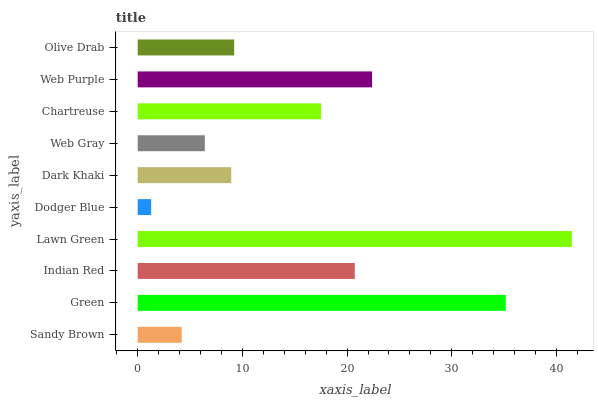Is Dodger Blue the minimum?
Answer yes or no. Yes. Is Lawn Green the maximum?
Answer yes or no. Yes. Is Green the minimum?
Answer yes or no. No. Is Green the maximum?
Answer yes or no. No. Is Green greater than Sandy Brown?
Answer yes or no. Yes. Is Sandy Brown less than Green?
Answer yes or no. Yes. Is Sandy Brown greater than Green?
Answer yes or no. No. Is Green less than Sandy Brown?
Answer yes or no. No. Is Chartreuse the high median?
Answer yes or no. Yes. Is Olive Drab the low median?
Answer yes or no. Yes. Is Dark Khaki the high median?
Answer yes or no. No. Is Web Purple the low median?
Answer yes or no. No. 